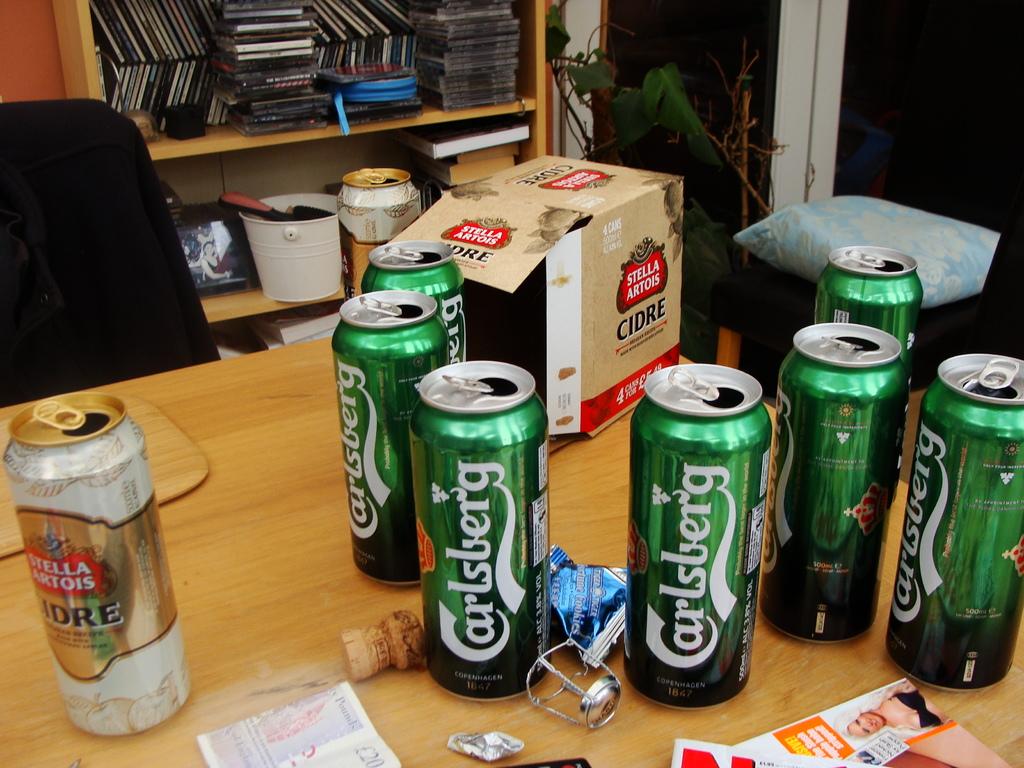What brand is the beer?
Provide a succinct answer. Carlsberg. What beer is in the green can?
Offer a very short reply. Carlsberg. 